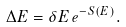<formula> <loc_0><loc_0><loc_500><loc_500>\Delta { E } = \delta { E } \, e ^ { - S ( E ) } .</formula> 